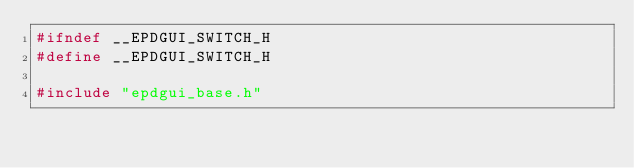<code> <loc_0><loc_0><loc_500><loc_500><_C_>#ifndef __EPDGUI_SWITCH_H
#define __EPDGUI_SWITCH_H

#include "epdgui_base.h"
</code> 